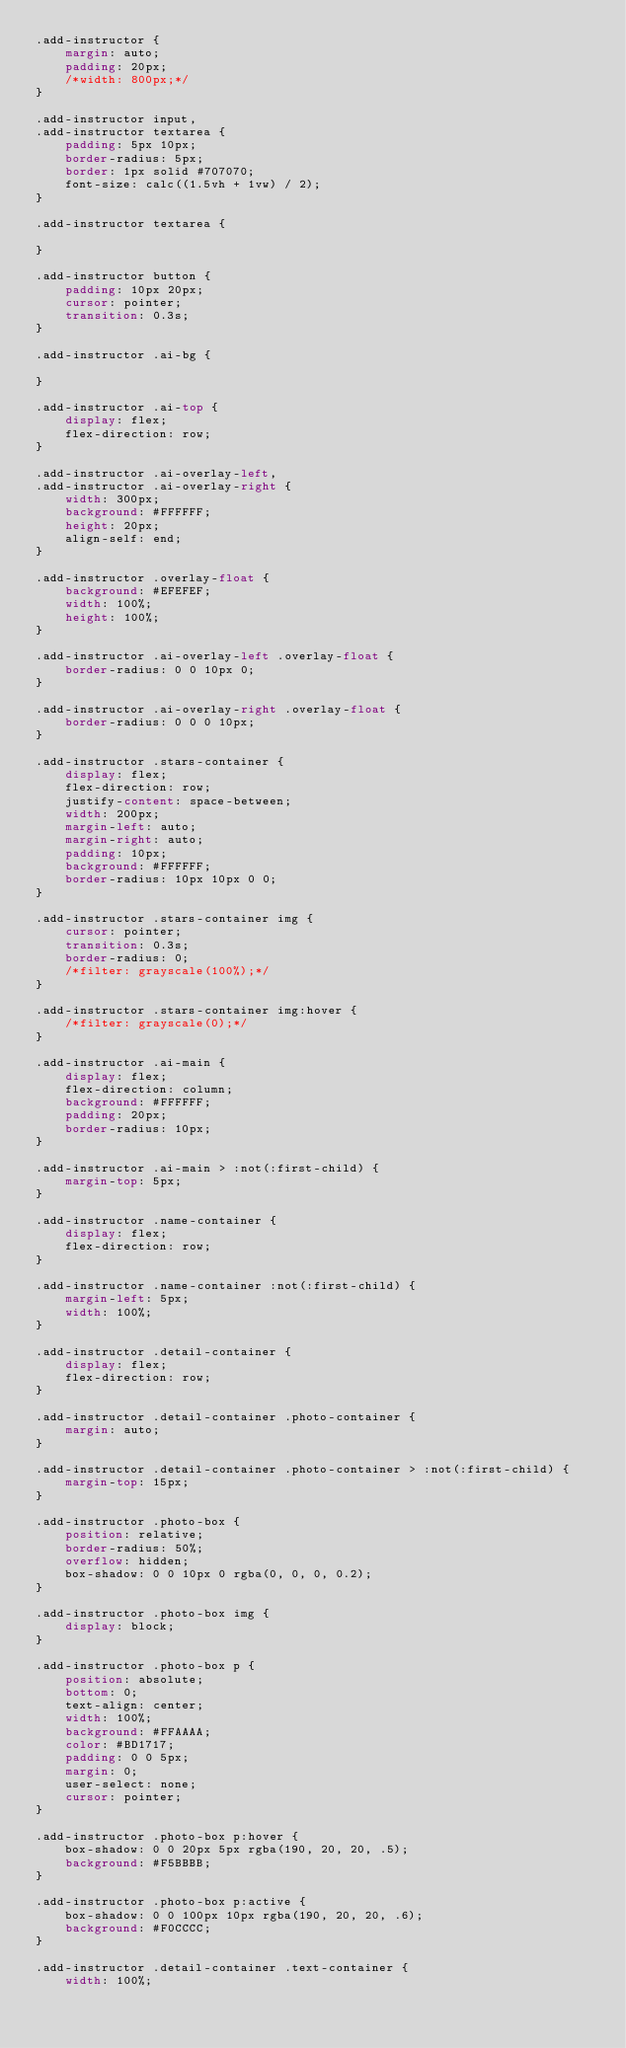Convert code to text. <code><loc_0><loc_0><loc_500><loc_500><_CSS_>.add-instructor {
    margin: auto;
    padding: 20px;
    /*width: 800px;*/
}

.add-instructor input,
.add-instructor textarea {
    padding: 5px 10px;
    border-radius: 5px;
    border: 1px solid #707070;
    font-size: calc((1.5vh + 1vw) / 2);
}

.add-instructor textarea {

}

.add-instructor button {
    padding: 10px 20px;
    cursor: pointer;
    transition: 0.3s;
}

.add-instructor .ai-bg {

}

.add-instructor .ai-top {
    display: flex;
    flex-direction: row;
}

.add-instructor .ai-overlay-left,
.add-instructor .ai-overlay-right {
    width: 300px;
    background: #FFFFFF;
    height: 20px;
    align-self: end;
}

.add-instructor .overlay-float {
    background: #EFEFEF;
    width: 100%;
    height: 100%;
}

.add-instructor .ai-overlay-left .overlay-float {
    border-radius: 0 0 10px 0;
}

.add-instructor .ai-overlay-right .overlay-float {
    border-radius: 0 0 0 10px;
}

.add-instructor .stars-container {
    display: flex;
    flex-direction: row;
    justify-content: space-between;
    width: 200px;
    margin-left: auto;
    margin-right: auto;
    padding: 10px;
    background: #FFFFFF;
    border-radius: 10px 10px 0 0;
}

.add-instructor .stars-container img {
    cursor: pointer;
    transition: 0.3s;
    border-radius: 0;
    /*filter: grayscale(100%);*/
}

.add-instructor .stars-container img:hover {
    /*filter: grayscale(0);*/
}

.add-instructor .ai-main {
    display: flex;
    flex-direction: column;
    background: #FFFFFF;
    padding: 20px;
    border-radius: 10px;
}

.add-instructor .ai-main > :not(:first-child) {
    margin-top: 5px;
}

.add-instructor .name-container {
    display: flex;
    flex-direction: row;
}

.add-instructor .name-container :not(:first-child) {
    margin-left: 5px;
    width: 100%;
}

.add-instructor .detail-container {
    display: flex;
    flex-direction: row;
}

.add-instructor .detail-container .photo-container {
    margin: auto;
}

.add-instructor .detail-container .photo-container > :not(:first-child) {
    margin-top: 15px;
}

.add-instructor .photo-box {
    position: relative;
    border-radius: 50%;
    overflow: hidden;
    box-shadow: 0 0 10px 0 rgba(0, 0, 0, 0.2);
}

.add-instructor .photo-box img {
    display: block;
}

.add-instructor .photo-box p {
    position: absolute;
    bottom: 0;
    text-align: center;
    width: 100%;
    background: #FFAAAA;
    color: #BD1717;
    padding: 0 0 5px;
    margin: 0;
    user-select: none;
    cursor: pointer;
}

.add-instructor .photo-box p:hover {
    box-shadow: 0 0 20px 5px rgba(190, 20, 20, .5);
    background: #F5BBBB;
}

.add-instructor .photo-box p:active {
    box-shadow: 0 0 100px 10px rgba(190, 20, 20, .6);
    background: #F0CCCC;
}

.add-instructor .detail-container .text-container {
    width: 100%;</code> 